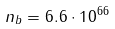Convert formula to latex. <formula><loc_0><loc_0><loc_500><loc_500>n _ { b } = 6 . 6 \cdot 1 0 ^ { 6 6 }</formula> 